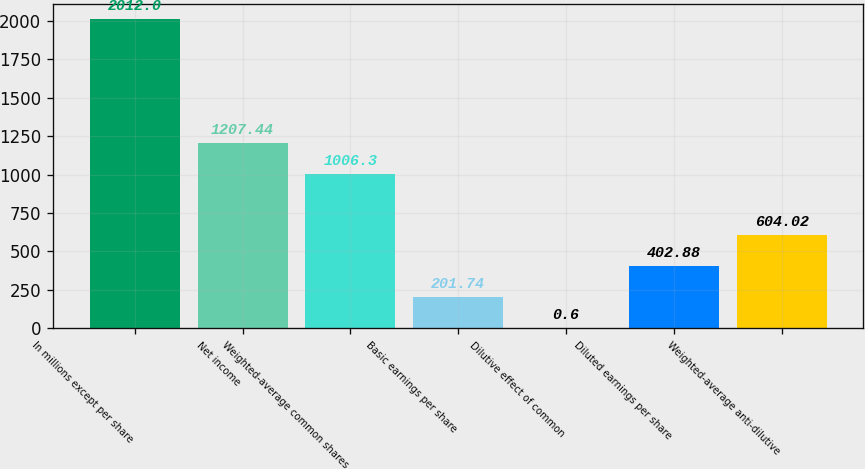Convert chart. <chart><loc_0><loc_0><loc_500><loc_500><bar_chart><fcel>In millions except per share<fcel>Net income<fcel>Weighted-average common shares<fcel>Basic earnings per share<fcel>Dilutive effect of common<fcel>Diluted earnings per share<fcel>Weighted-average anti-dilutive<nl><fcel>2012<fcel>1207.44<fcel>1006.3<fcel>201.74<fcel>0.6<fcel>402.88<fcel>604.02<nl></chart> 